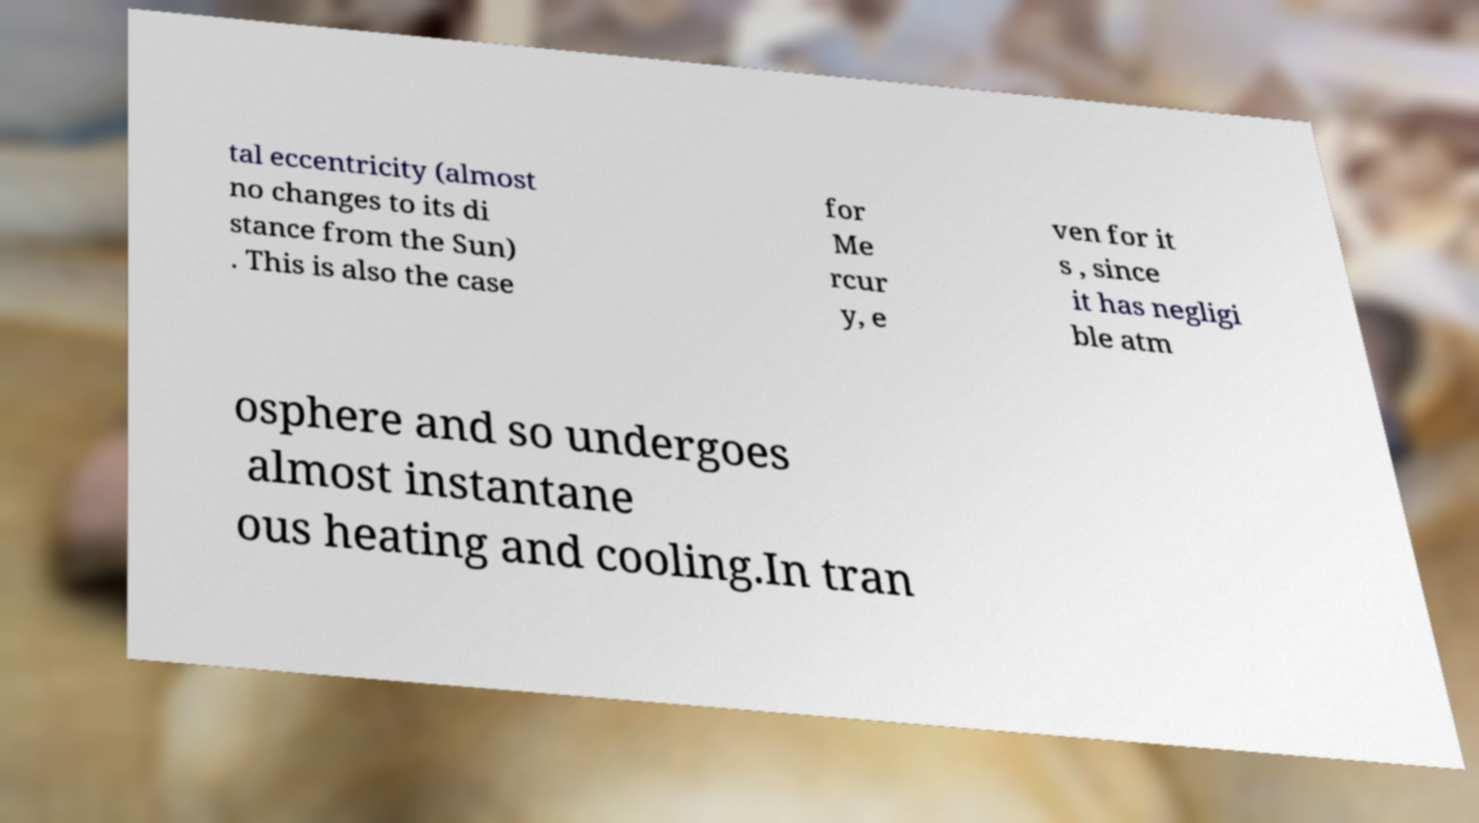Please identify and transcribe the text found in this image. tal eccentricity (almost no changes to its di stance from the Sun) . This is also the case for Me rcur y, e ven for it s , since it has negligi ble atm osphere and so undergoes almost instantane ous heating and cooling.In tran 